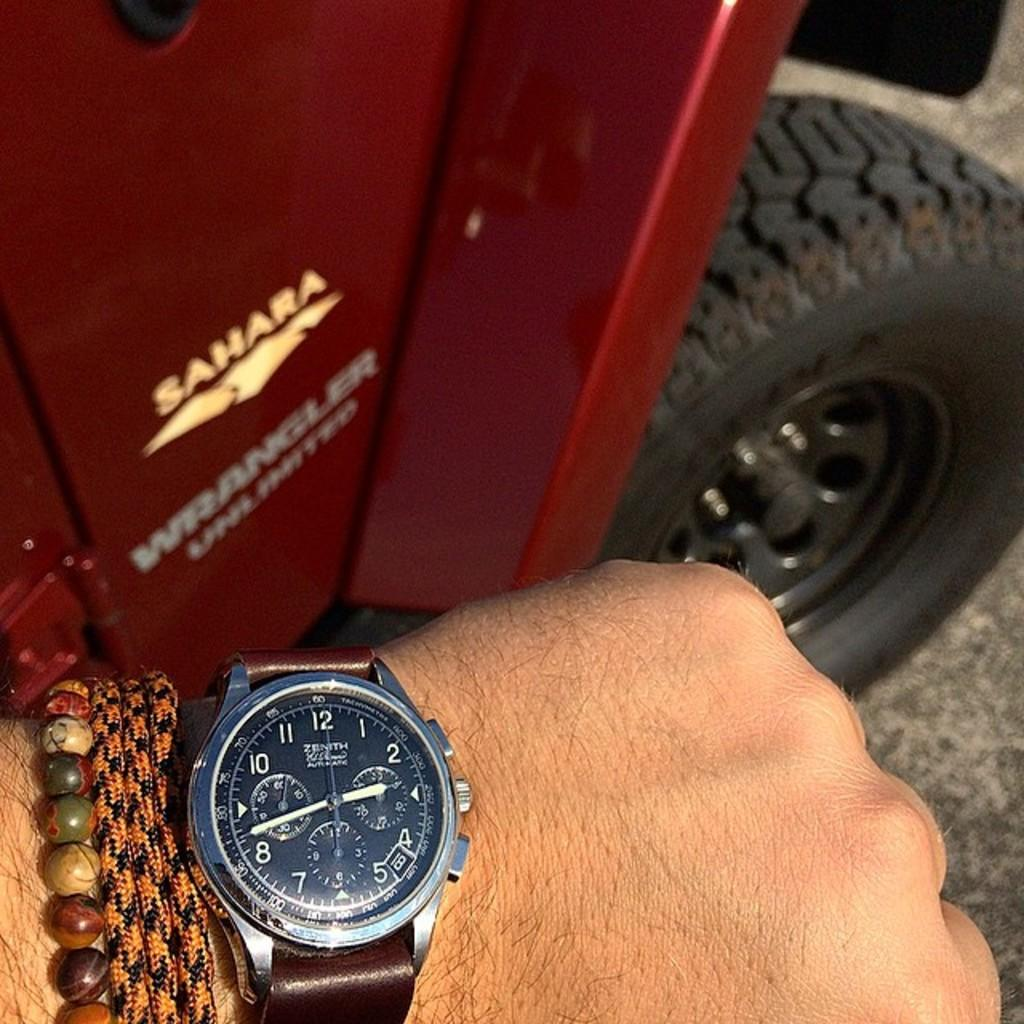Provide a one-sentence caption for the provided image. The Sahara Jeep Wrangler is great for going off road. 